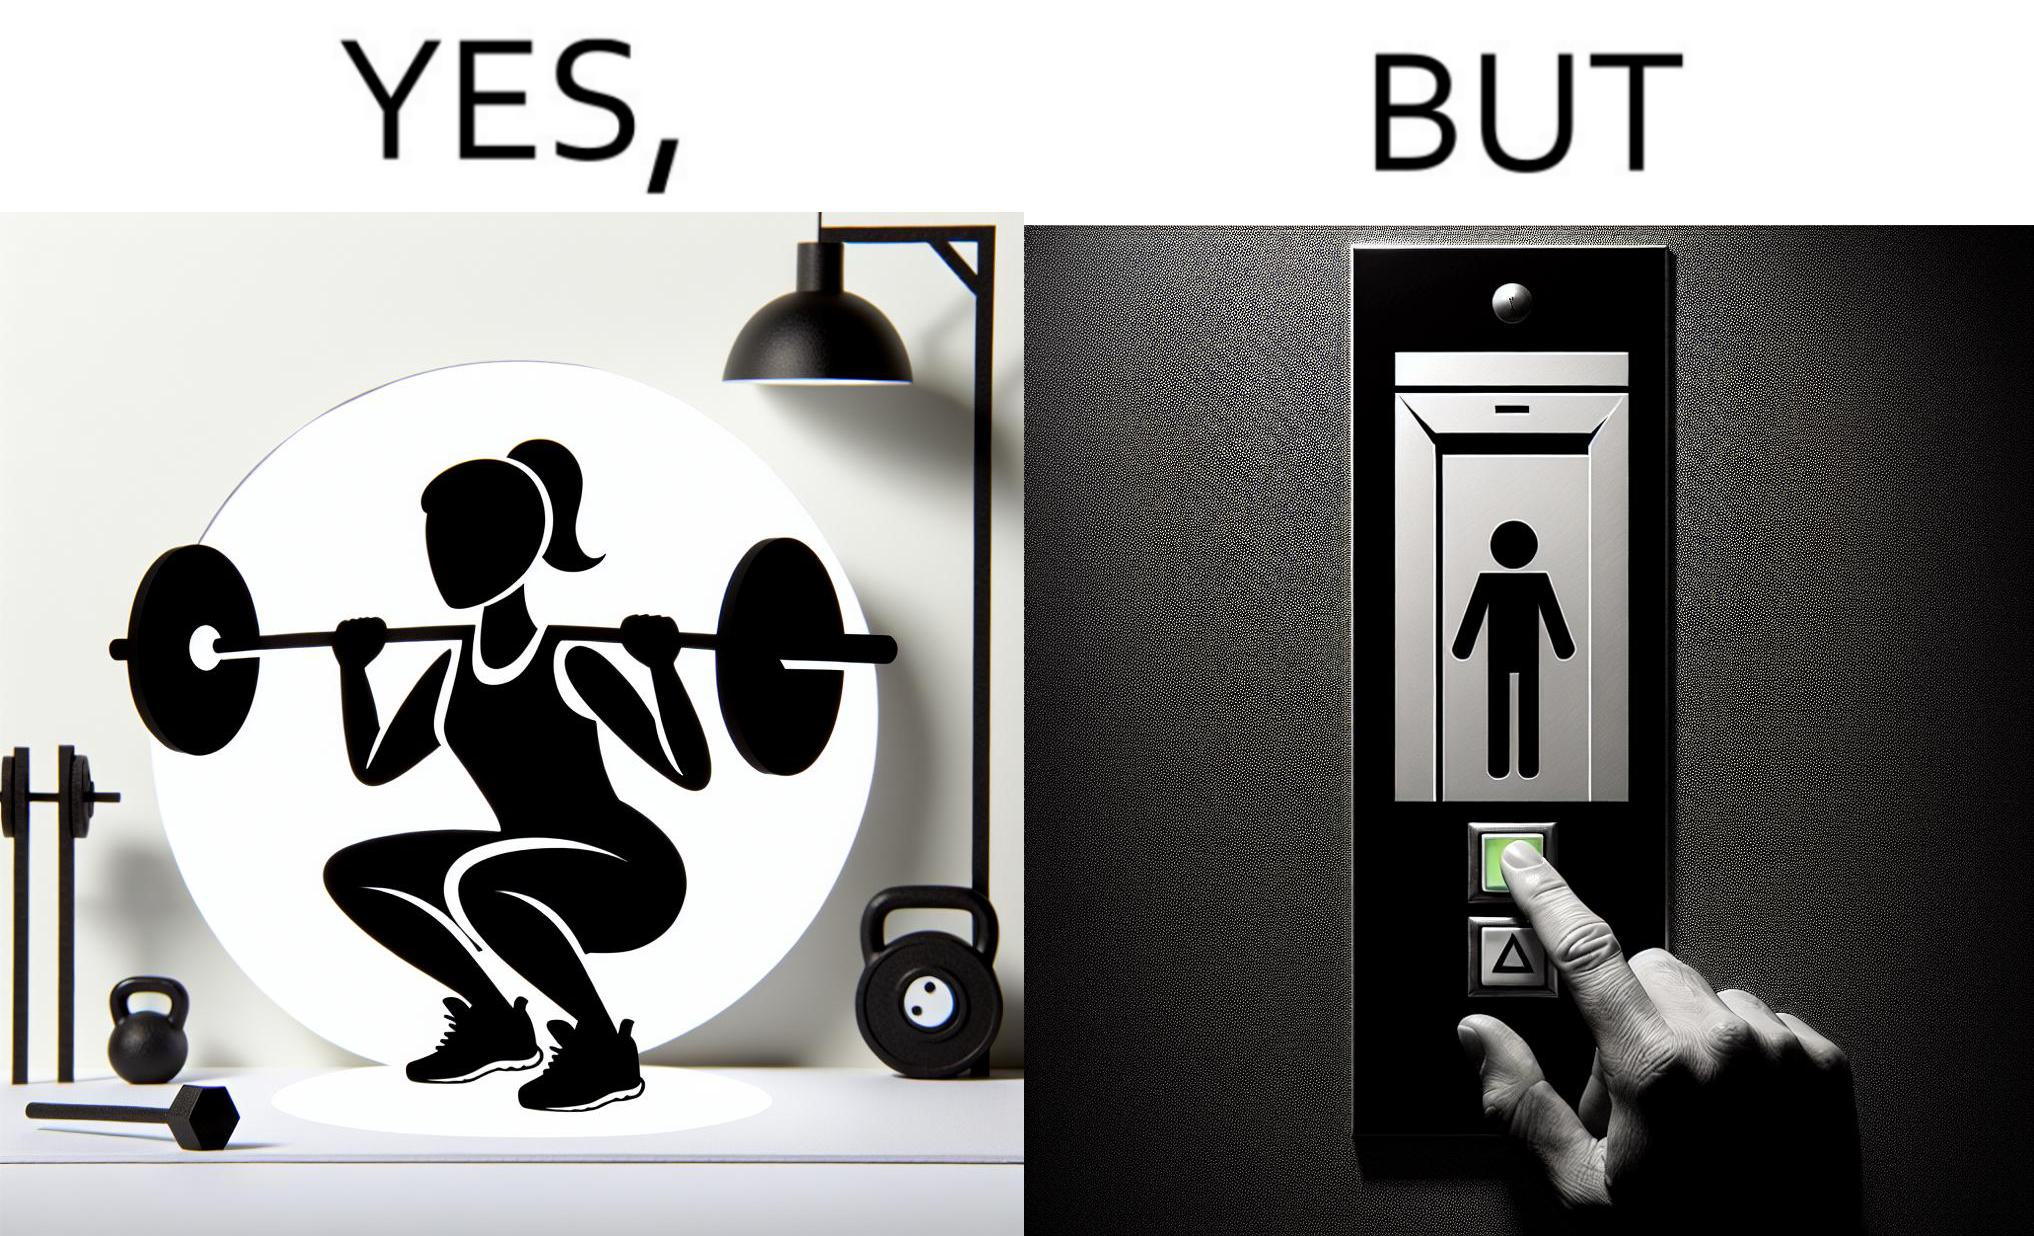What does this image depict? The image is satirical because it shows that while people do various kinds of exercises and go to gym to stay fit, they avoid doing simplest of physical tasks like using stairs instead of elevators to get to even the first or the second floor of a building. 